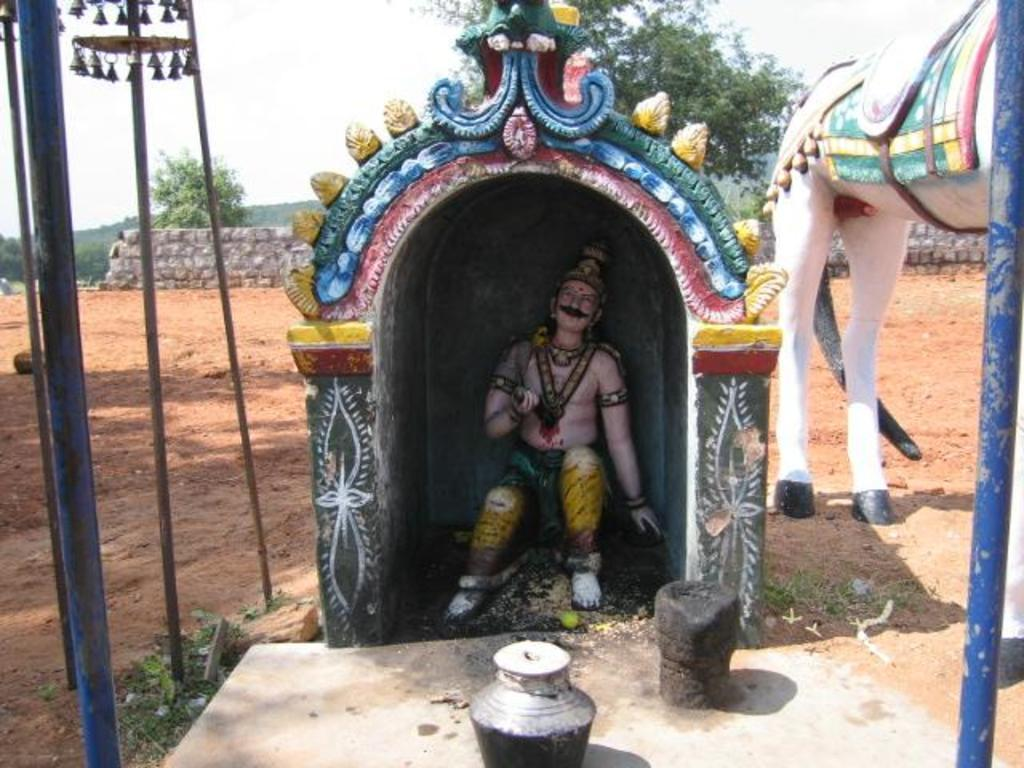What is located under the roof in the image? There is a statue under a roof in the image. What type of statue is present besides the one under the roof? There is another statue of an animal in the image. What can be seen in the background of the image? There are trees and a fence wall in the background of the image. What type of substance is the statue made of in the image? The provided facts do not mention the material or substance the statues are made of, so it cannot be determined from the image. Can you tell me if there is a signed agreement between the statues in the image? There is no indication of any agreement or interaction between the statues in the image. 